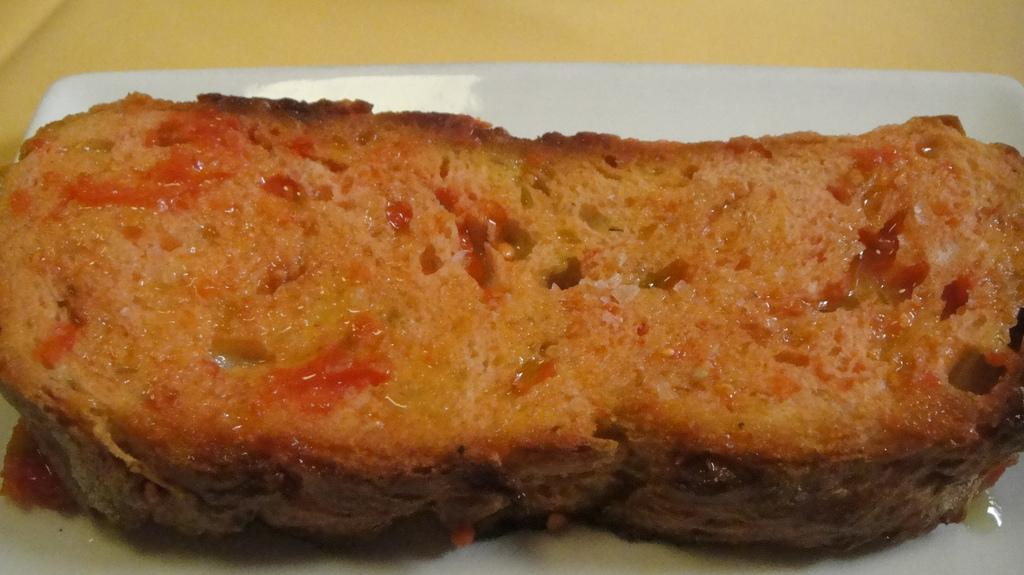What is: What is on the plate in the image? There is a food item on a plate in the image. Where is the plate located? The plate is placed on a surface. What team is responsible for preparing the breakfast in the image? There is no team or breakfast present in the image; it only shows a food item on a plate. Is there a bear visible in the image? No, there is no bear present in the image. 